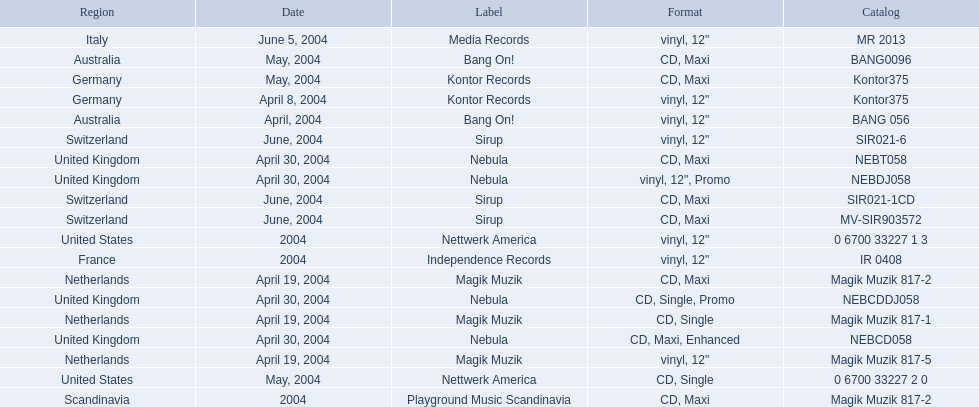What label was used by the netherlands in love comes again? Magik Muzik. What label was used in germany? Kontor Records. What label was used in france? Independence Records. 